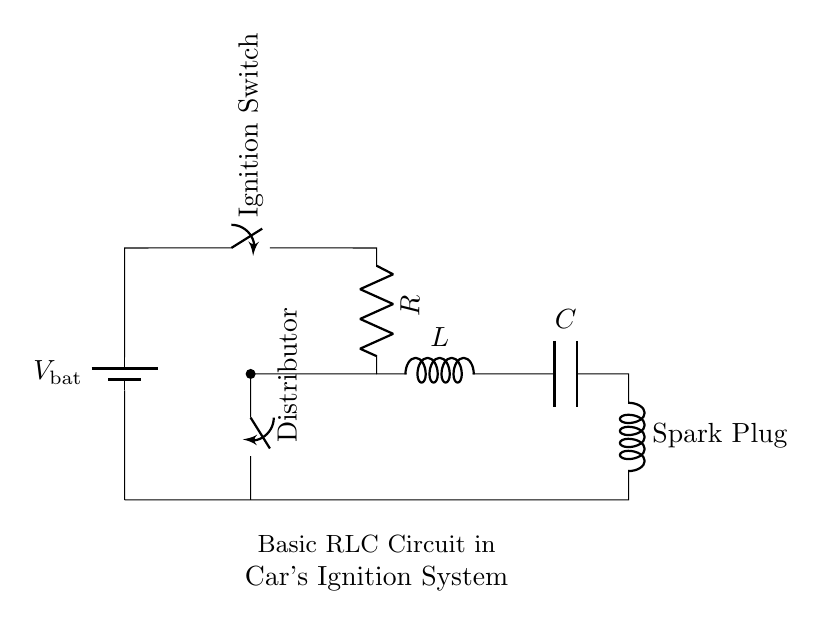What is the voltage source in this circuit? The circuit features a voltage source, represented by the battery symbol, which is labeled as V_bat. This is the power supply for the entire circuit.
Answer: V_bat What component is connected between the battery and the resistor? The ignition switch is the component that connects the battery to the resistor. This switch controls the flow of electrical current in the circuit.
Answer: Ignition Switch How many capacitors are in the circuit? There is one capacitor in the circuit, identified by the C symbol. Capacitors store electrical energy and are crucial in managing the timing and discharge in this circuit.
Answer: One What does the inductor do in this ignition system? The inductor, marked as L, stores energy in a magnetic field when current flows through it. In this circuit, it regulates the current and plays a critical role in generating the spark timing necessary for engine ignition.
Answer: Stores energy What is the role of the spark plug in this circuit? The spark plug is responsible for igniting the air-fuel mixture in the engine's cylinders at the correct moment, utilizing the electrical energy delivered through the circuit to create a spark.
Answer: Ignites the air-fuel mixture What type of circuit is represented in the diagram? The diagram represents an RLC circuit, which stands for a circuit containing a Resistor, Inductor, and Capacitor. This specific arrangement is commonly used in ignition systems for timing the spark for engine performance.
Answer: RLC Circuit 